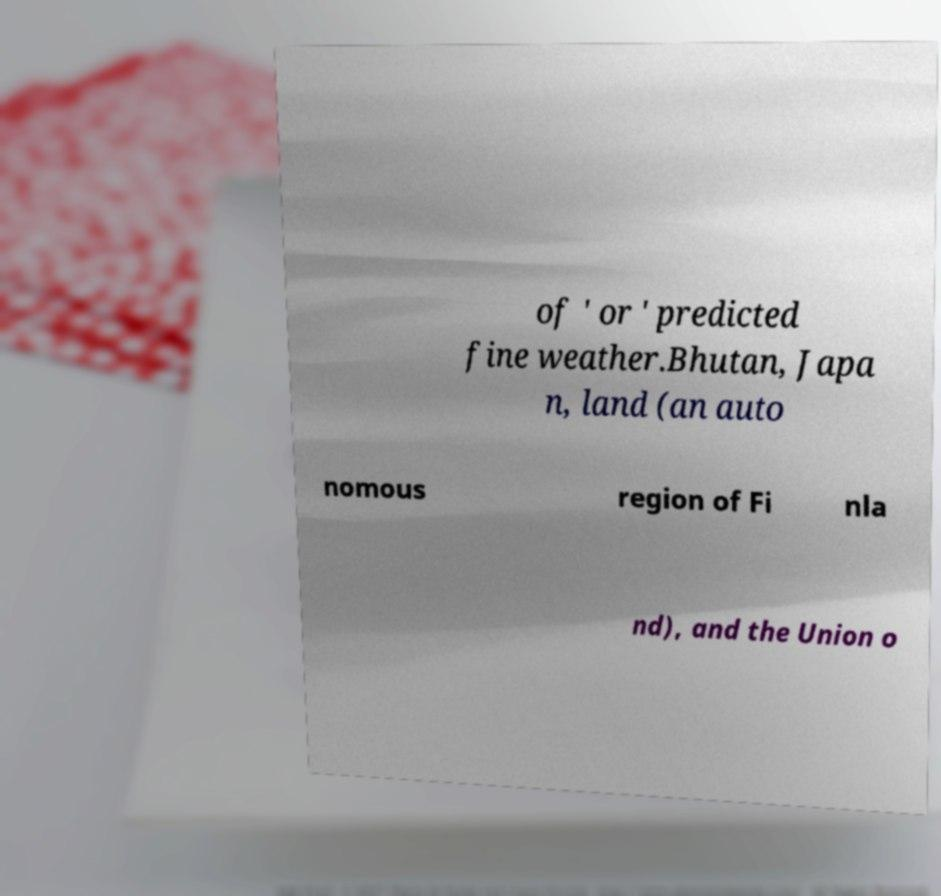Please read and relay the text visible in this image. What does it say? of ' or ' predicted fine weather.Bhutan, Japa n, land (an auto nomous region of Fi nla nd), and the Union o 